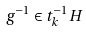Convert formula to latex. <formula><loc_0><loc_0><loc_500><loc_500>g ^ { - 1 } \in t _ { k } ^ { - 1 } H</formula> 